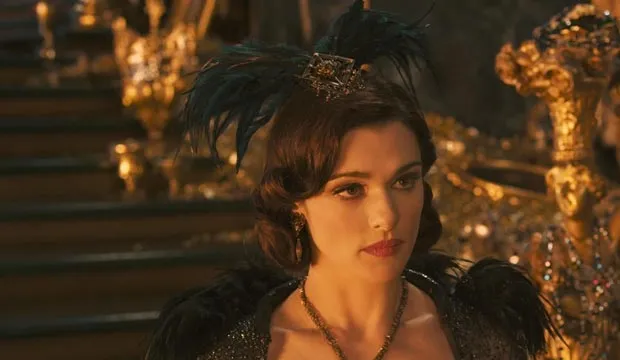If Evanora could have a pet, what would it be and why? Evanora would likely have a majestic black panther as her pet. The panther symbolizes her power, grace, and mysterious allure. This elegant yet formidable creature would complement her personality, serving as a loyal guardian and a silent testament to her strength and regal presence. 